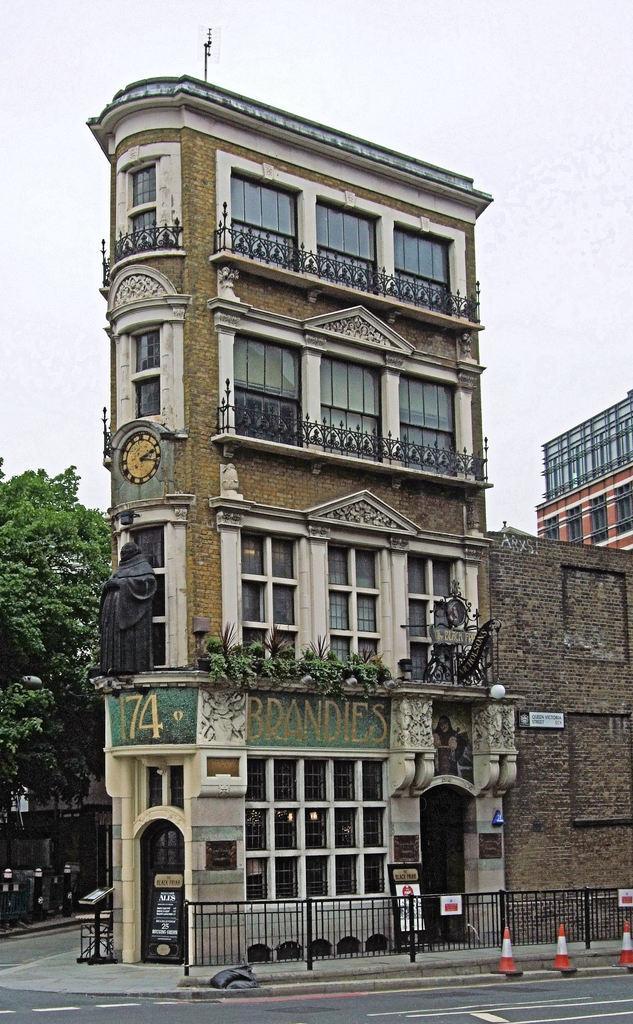How would you summarize this image in a sentence or two? This is an outside view. At the bottom of the image I can see the road, railing and footpath. Here I can see a building. On the left side there is a tree. On the top of the image I can see the sky. In front of this building I can see a statue of a person. 